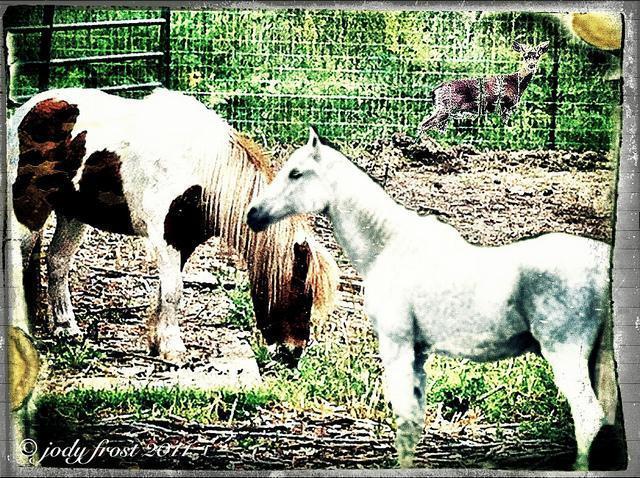How many animals are in this picture?
Give a very brief answer. 3. How many of the animals shown are being raised for their meat?
Give a very brief answer. 0. How many horses can be seen?
Give a very brief answer. 2. How many people are holding a baseball bat?
Give a very brief answer. 0. 